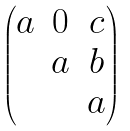Convert formula to latex. <formula><loc_0><loc_0><loc_500><loc_500>\begin{pmatrix} a & 0 & c \\ & a & b \\ & & a \end{pmatrix}</formula> 